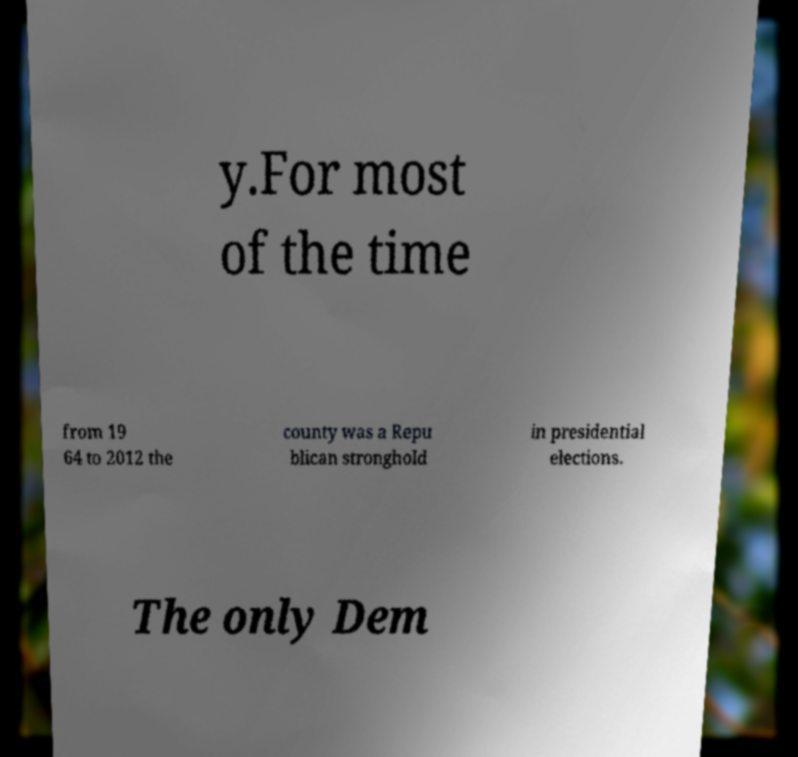What messages or text are displayed in this image? I need them in a readable, typed format. y.For most of the time from 19 64 to 2012 the county was a Repu blican stronghold in presidential elections. The only Dem 